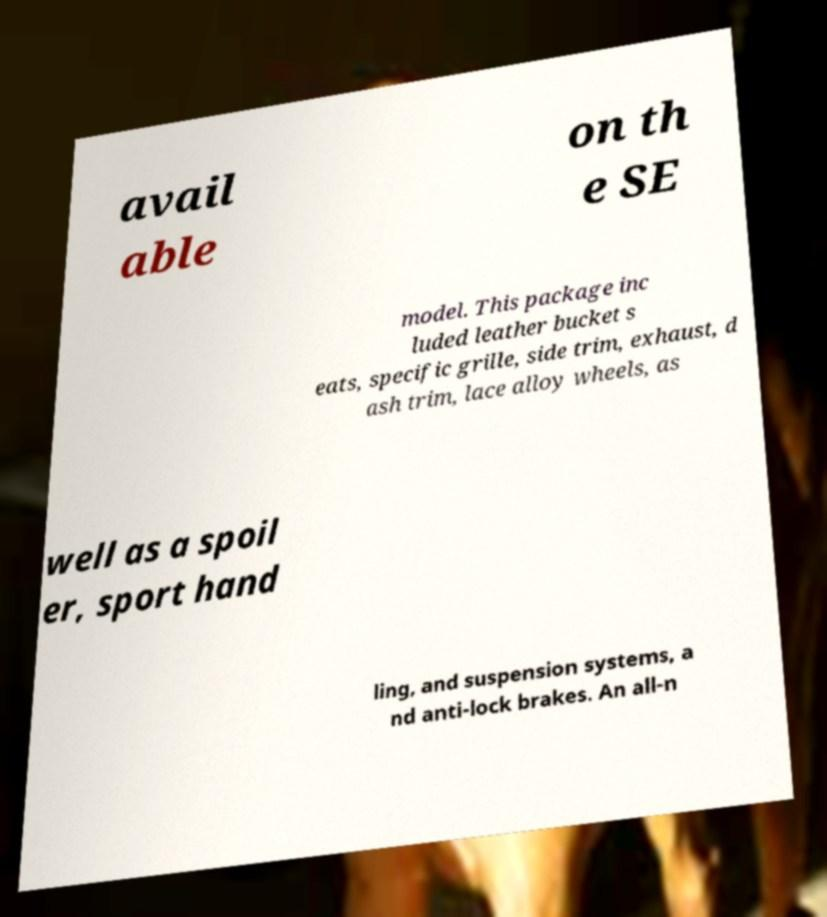There's text embedded in this image that I need extracted. Can you transcribe it verbatim? avail able on th e SE model. This package inc luded leather bucket s eats, specific grille, side trim, exhaust, d ash trim, lace alloy wheels, as well as a spoil er, sport hand ling, and suspension systems, a nd anti-lock brakes. An all-n 